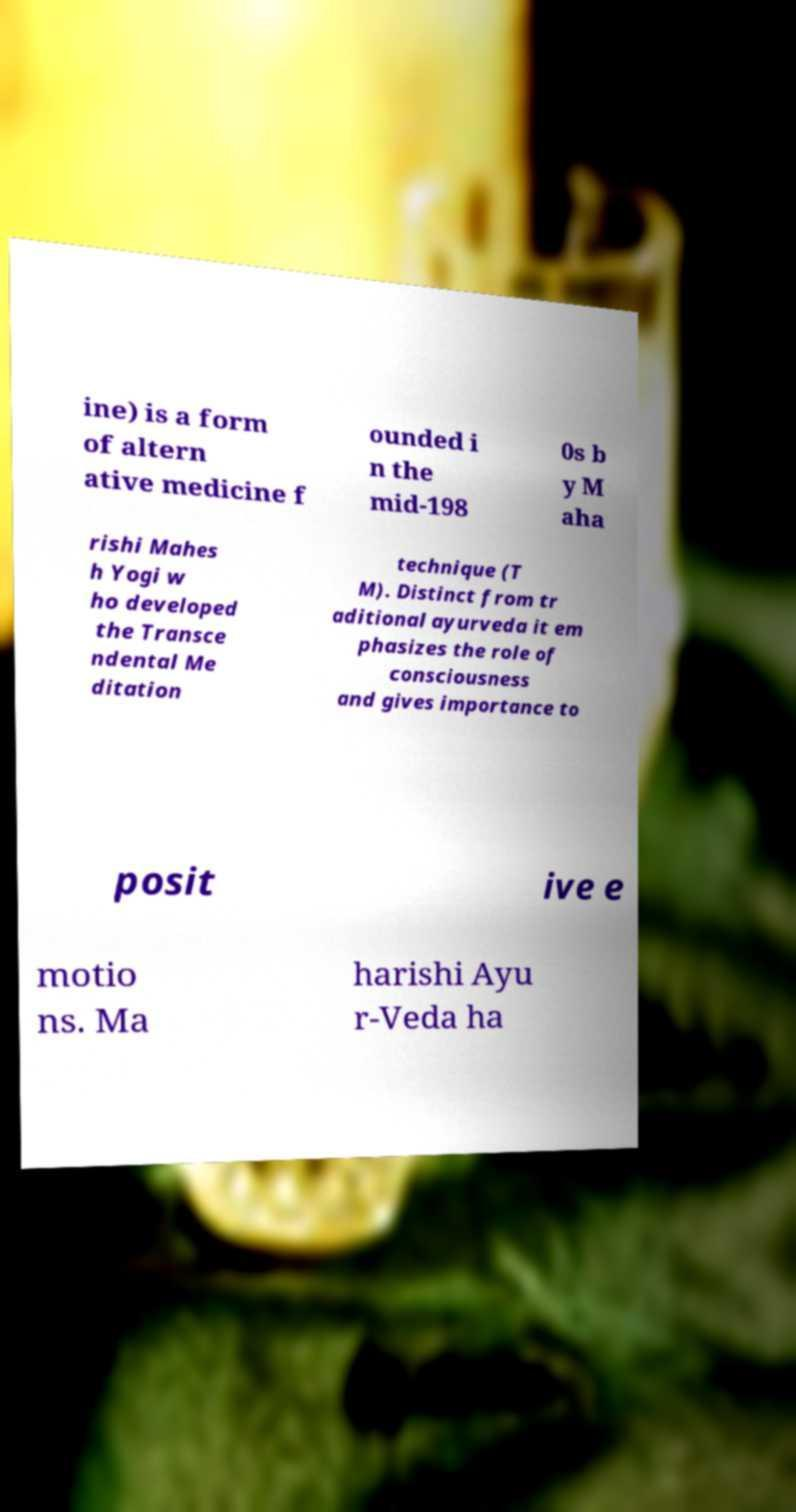For documentation purposes, I need the text within this image transcribed. Could you provide that? ine) is a form of altern ative medicine f ounded i n the mid-198 0s b y M aha rishi Mahes h Yogi w ho developed the Transce ndental Me ditation technique (T M). Distinct from tr aditional ayurveda it em phasizes the role of consciousness and gives importance to posit ive e motio ns. Ma harishi Ayu r-Veda ha 